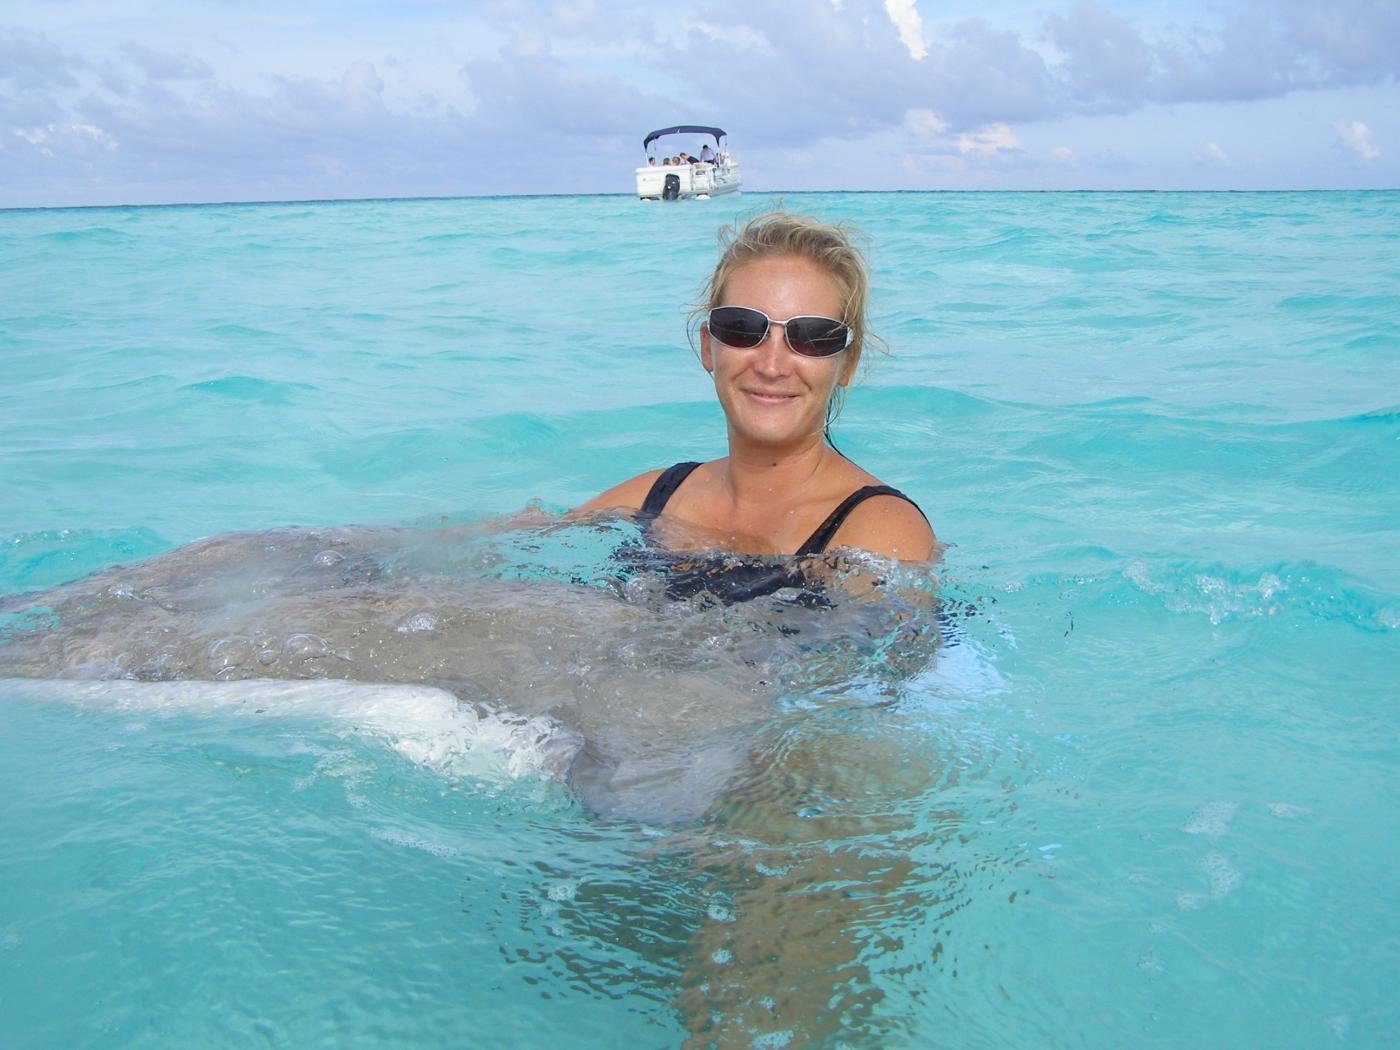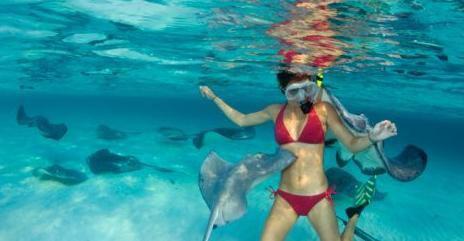The first image is the image on the left, the second image is the image on the right. For the images displayed, is the sentence "Two or more people are in very clear ocean water with manta rays swimming around them." factually correct? Answer yes or no. Yes. The first image is the image on the left, the second image is the image on the right. Assess this claim about the two images: "There is at least one person in the water with at least one manta ray.". Correct or not? Answer yes or no. Yes. 